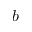<formula> <loc_0><loc_0><loc_500><loc_500>b</formula> 